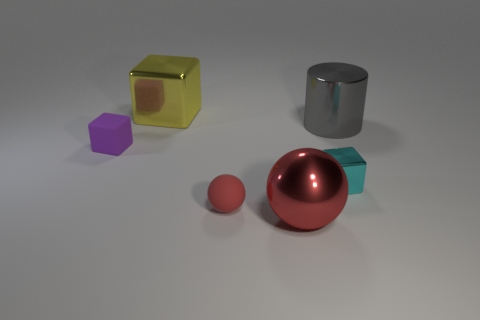Subtract all cylinders. How many objects are left? 5 Subtract all cyan cubes. How many cubes are left? 2 Subtract all tiny blocks. How many blocks are left? 1 Subtract 0 brown blocks. How many objects are left? 6 Subtract 1 cylinders. How many cylinders are left? 0 Subtract all yellow cylinders. Subtract all red blocks. How many cylinders are left? 1 Subtract all green balls. How many yellow cubes are left? 1 Subtract all small purple rubber cylinders. Subtract all cylinders. How many objects are left? 5 Add 6 large objects. How many large objects are left? 9 Add 5 large matte cylinders. How many large matte cylinders exist? 5 